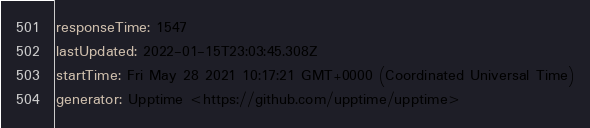Convert code to text. <code><loc_0><loc_0><loc_500><loc_500><_YAML_>responseTime: 1547
lastUpdated: 2022-01-15T23:03:45.308Z
startTime: Fri May 28 2021 10:17:21 GMT+0000 (Coordinated Universal Time)
generator: Upptime <https://github.com/upptime/upptime>
</code> 